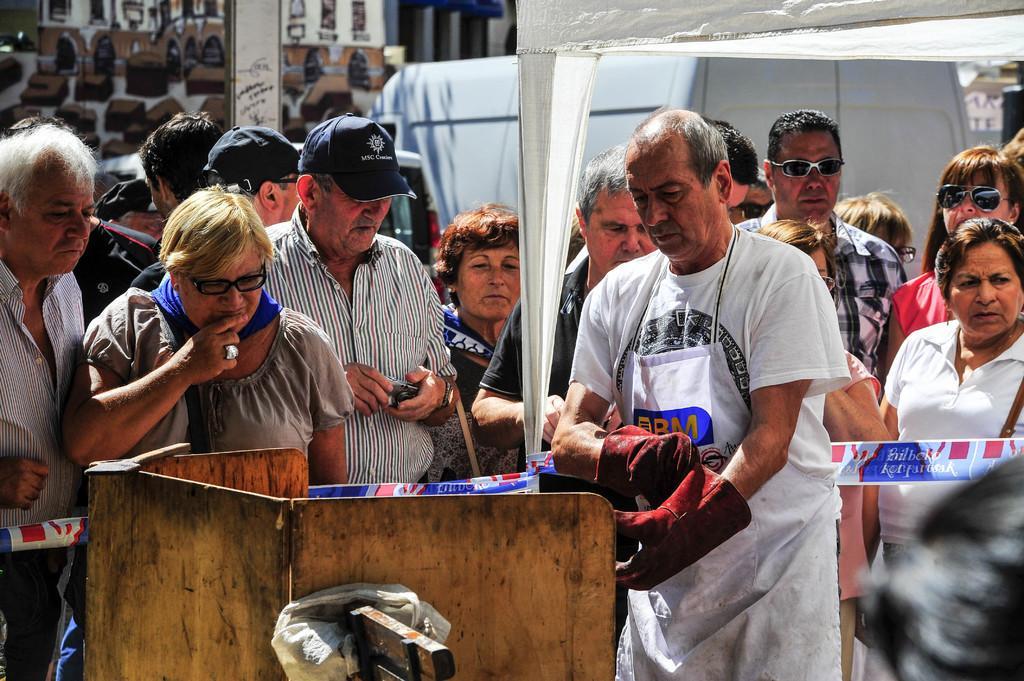Could you give a brief overview of what you see in this image? In this image there are some persons standing in middle of this image and there is a building in the background. There is an object kept in the bottom of this image. 